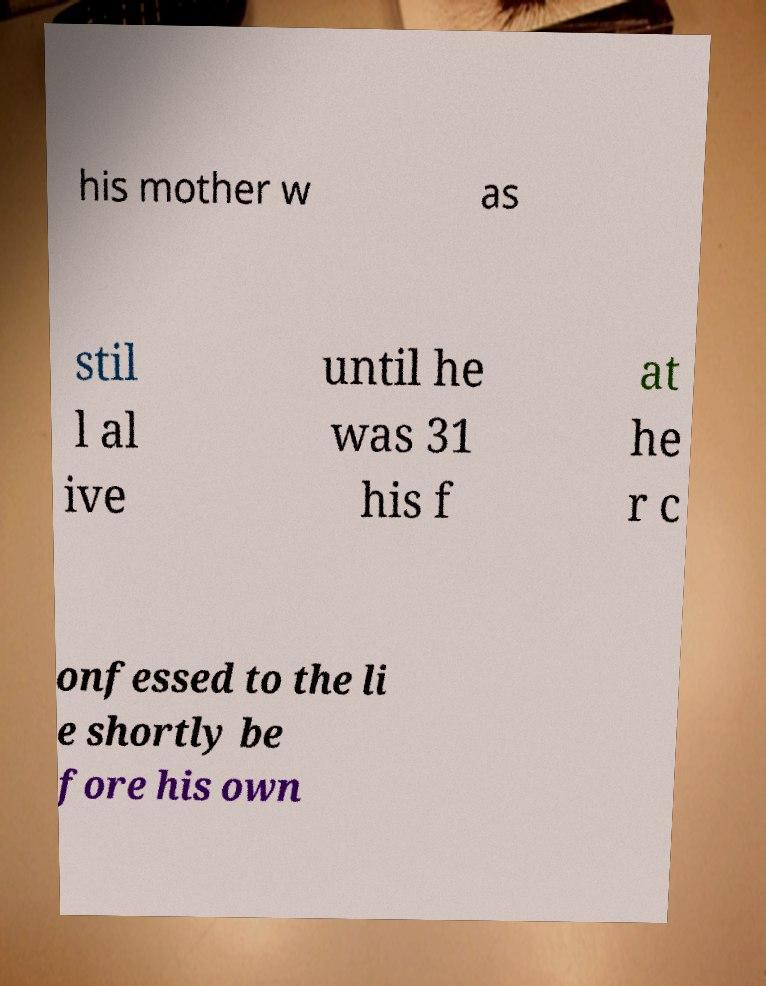Could you assist in decoding the text presented in this image and type it out clearly? his mother w as stil l al ive until he was 31 his f at he r c onfessed to the li e shortly be fore his own 